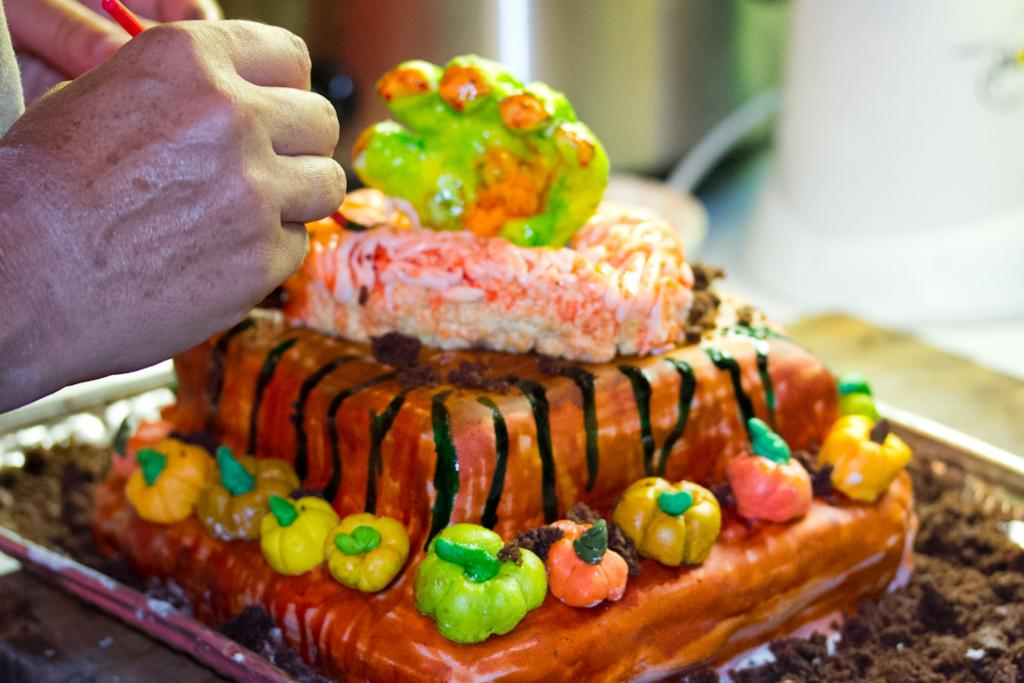What is the main subject of the image? There is a person in the image. What is the person doing in the image? The person is making a cake. How many jellyfish are swimming in the cake batter in the image? There are no jellyfish present in the image, as it features a person making a cake. What type of goose can be seen helping the person make the cake in the image? There is no goose present in the image; it only shows a person making a cake. 